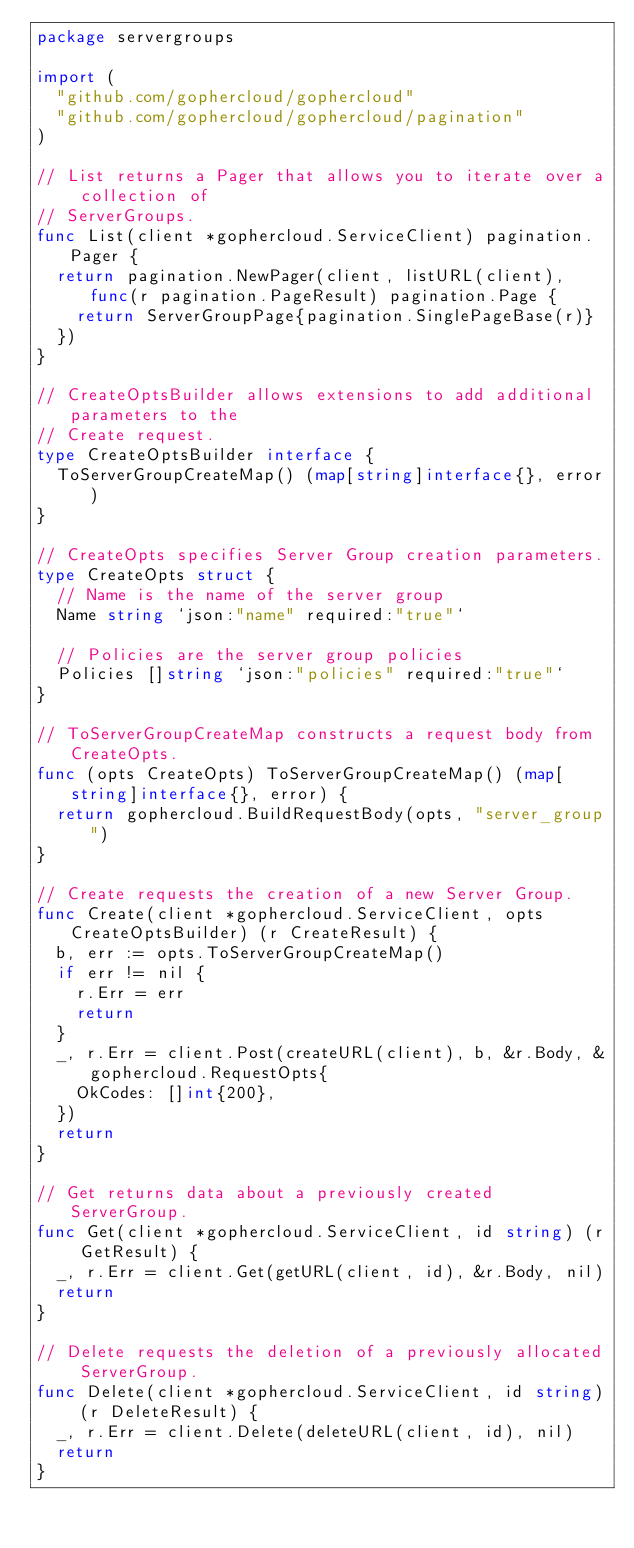<code> <loc_0><loc_0><loc_500><loc_500><_Go_>package servergroups

import (
	"github.com/gophercloud/gophercloud"
	"github.com/gophercloud/gophercloud/pagination"
)

// List returns a Pager that allows you to iterate over a collection of
// ServerGroups.
func List(client *gophercloud.ServiceClient) pagination.Pager {
	return pagination.NewPager(client, listURL(client), func(r pagination.PageResult) pagination.Page {
		return ServerGroupPage{pagination.SinglePageBase(r)}
	})
}

// CreateOptsBuilder allows extensions to add additional parameters to the
// Create request.
type CreateOptsBuilder interface {
	ToServerGroupCreateMap() (map[string]interface{}, error)
}

// CreateOpts specifies Server Group creation parameters.
type CreateOpts struct {
	// Name is the name of the server group
	Name string `json:"name" required:"true"`

	// Policies are the server group policies
	Policies []string `json:"policies" required:"true"`
}

// ToServerGroupCreateMap constructs a request body from CreateOpts.
func (opts CreateOpts) ToServerGroupCreateMap() (map[string]interface{}, error) {
	return gophercloud.BuildRequestBody(opts, "server_group")
}

// Create requests the creation of a new Server Group.
func Create(client *gophercloud.ServiceClient, opts CreateOptsBuilder) (r CreateResult) {
	b, err := opts.ToServerGroupCreateMap()
	if err != nil {
		r.Err = err
		return
	}
	_, r.Err = client.Post(createURL(client), b, &r.Body, &gophercloud.RequestOpts{
		OkCodes: []int{200},
	})
	return
}

// Get returns data about a previously created ServerGroup.
func Get(client *gophercloud.ServiceClient, id string) (r GetResult) {
	_, r.Err = client.Get(getURL(client, id), &r.Body, nil)
	return
}

// Delete requests the deletion of a previously allocated ServerGroup.
func Delete(client *gophercloud.ServiceClient, id string) (r DeleteResult) {
	_, r.Err = client.Delete(deleteURL(client, id), nil)
	return
}
</code> 